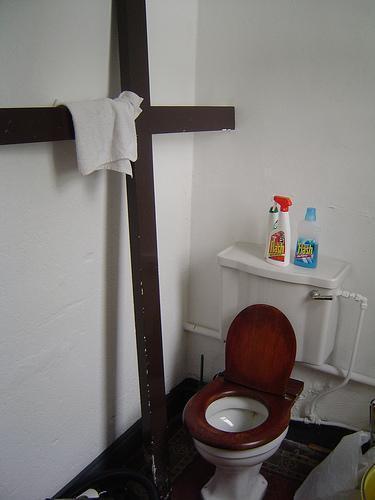How many toilets are in the picture?
Give a very brief answer. 1. 